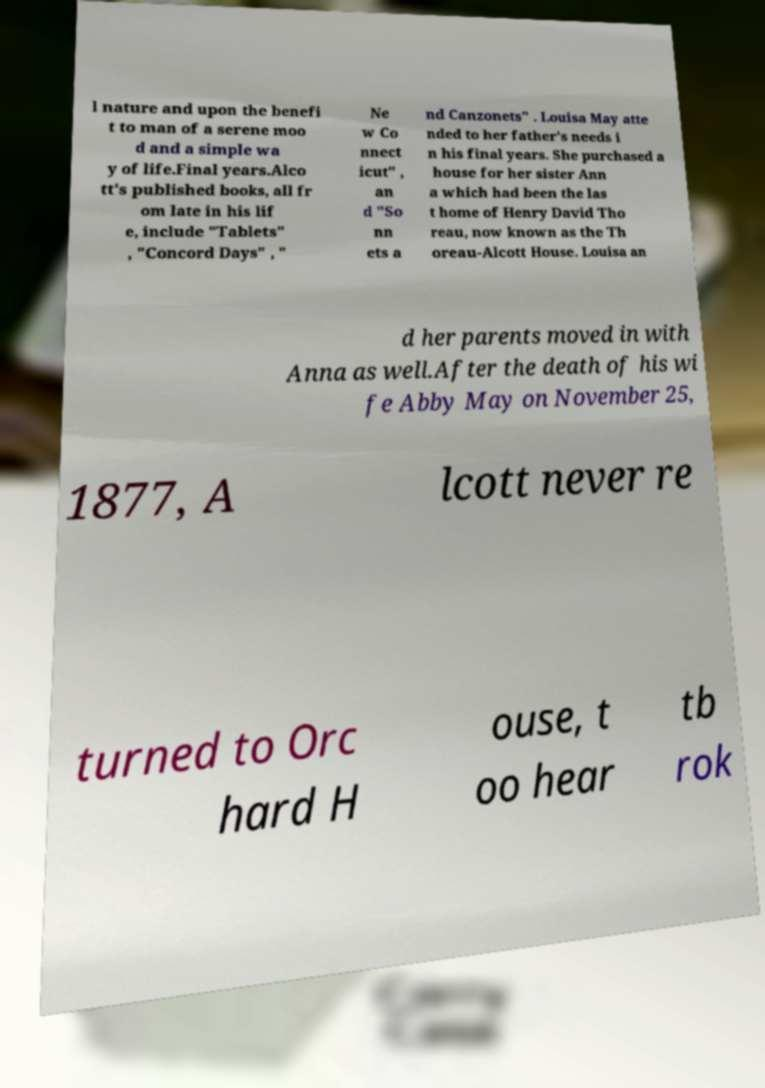Can you read and provide the text displayed in the image?This photo seems to have some interesting text. Can you extract and type it out for me? l nature and upon the benefi t to man of a serene moo d and a simple wa y of life.Final years.Alco tt's published books, all fr om late in his lif e, include "Tablets" , "Concord Days" , " Ne w Co nnect icut" , an d "So nn ets a nd Canzonets" . Louisa May atte nded to her father's needs i n his final years. She purchased a house for her sister Ann a which had been the las t home of Henry David Tho reau, now known as the Th oreau-Alcott House. Louisa an d her parents moved in with Anna as well.After the death of his wi fe Abby May on November 25, 1877, A lcott never re turned to Orc hard H ouse, t oo hear tb rok 